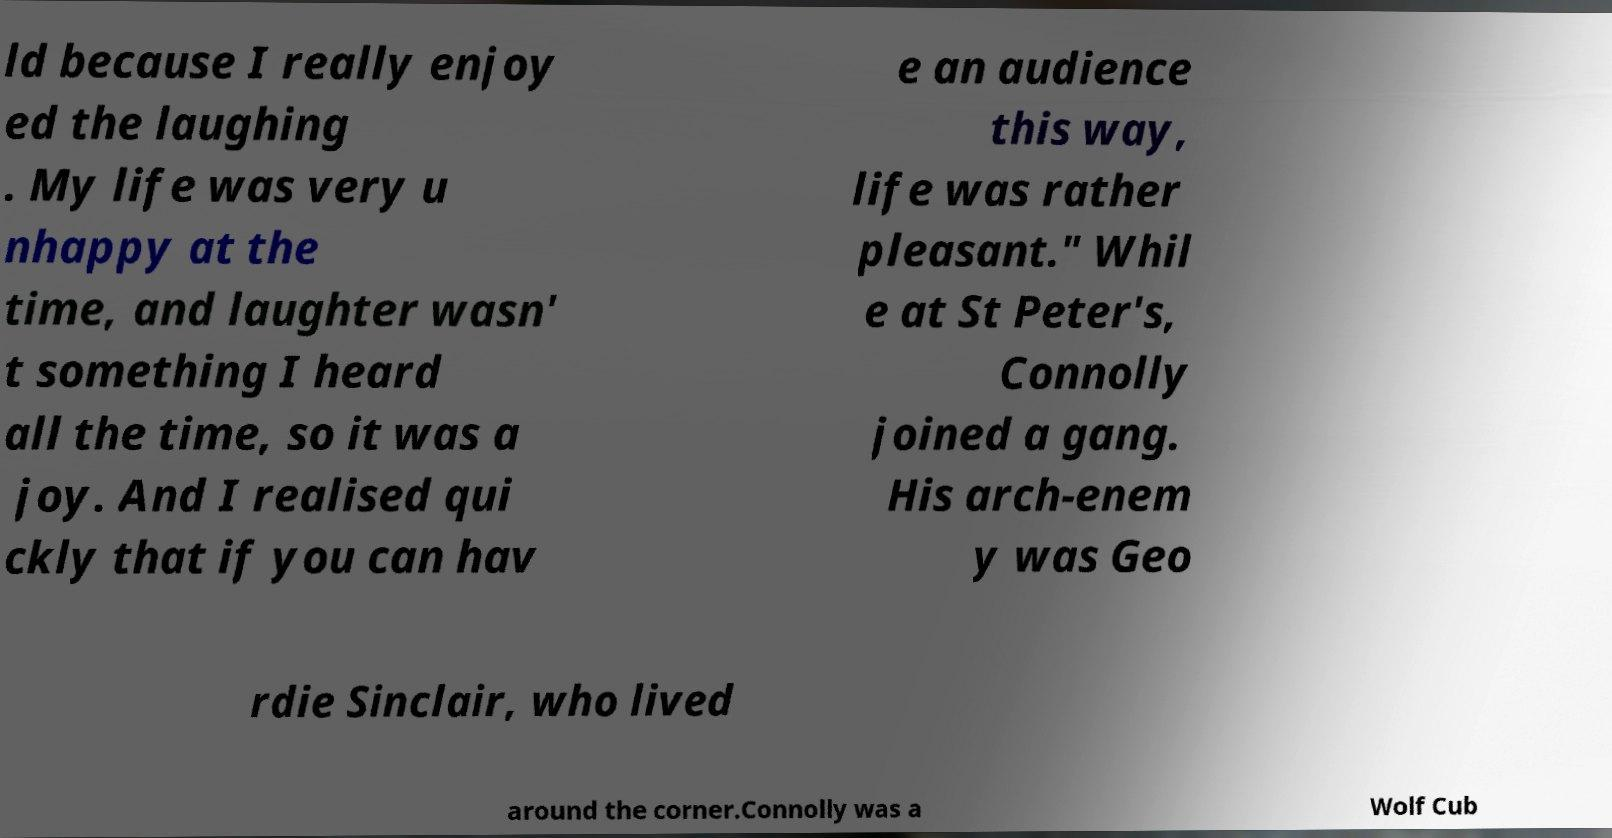Please read and relay the text visible in this image. What does it say? ld because I really enjoy ed the laughing . My life was very u nhappy at the time, and laughter wasn' t something I heard all the time, so it was a joy. And I realised qui ckly that if you can hav e an audience this way, life was rather pleasant." Whil e at St Peter's, Connolly joined a gang. His arch-enem y was Geo rdie Sinclair, who lived around the corner.Connolly was a Wolf Cub 